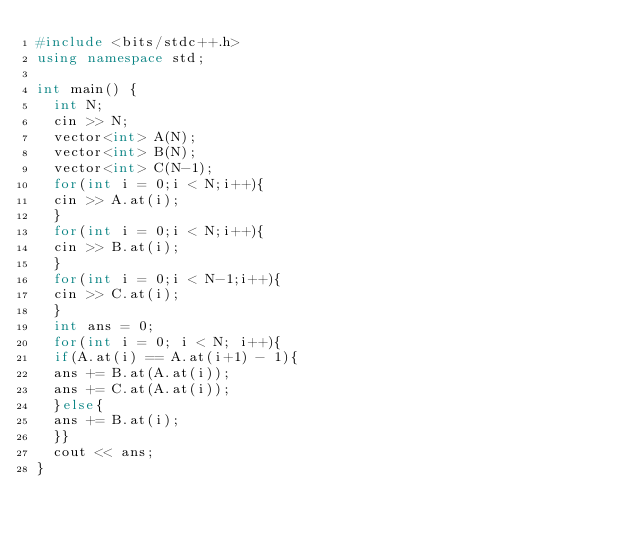Convert code to text. <code><loc_0><loc_0><loc_500><loc_500><_C++_>#include <bits/stdc++.h>
using namespace std;

int main() {
  int N;
  cin >> N;
  vector<int> A(N);
  vector<int> B(N);
  vector<int> C(N-1);
  for(int i = 0;i < N;i++){
  cin >> A.at(i);
  }
  for(int i = 0;i < N;i++){
  cin >> B.at(i);
  }
  for(int i = 0;i < N-1;i++){
  cin >> C.at(i);
  }
  int ans = 0;
  for(int i = 0; i < N; i++){
  if(A.at(i) == A.at(i+1) - 1){
  ans += B.at(A.at(i));
  ans += C.at(A.at(i));
  }else{
  ans += B.at(i);
  }}
  cout << ans;
}
</code> 